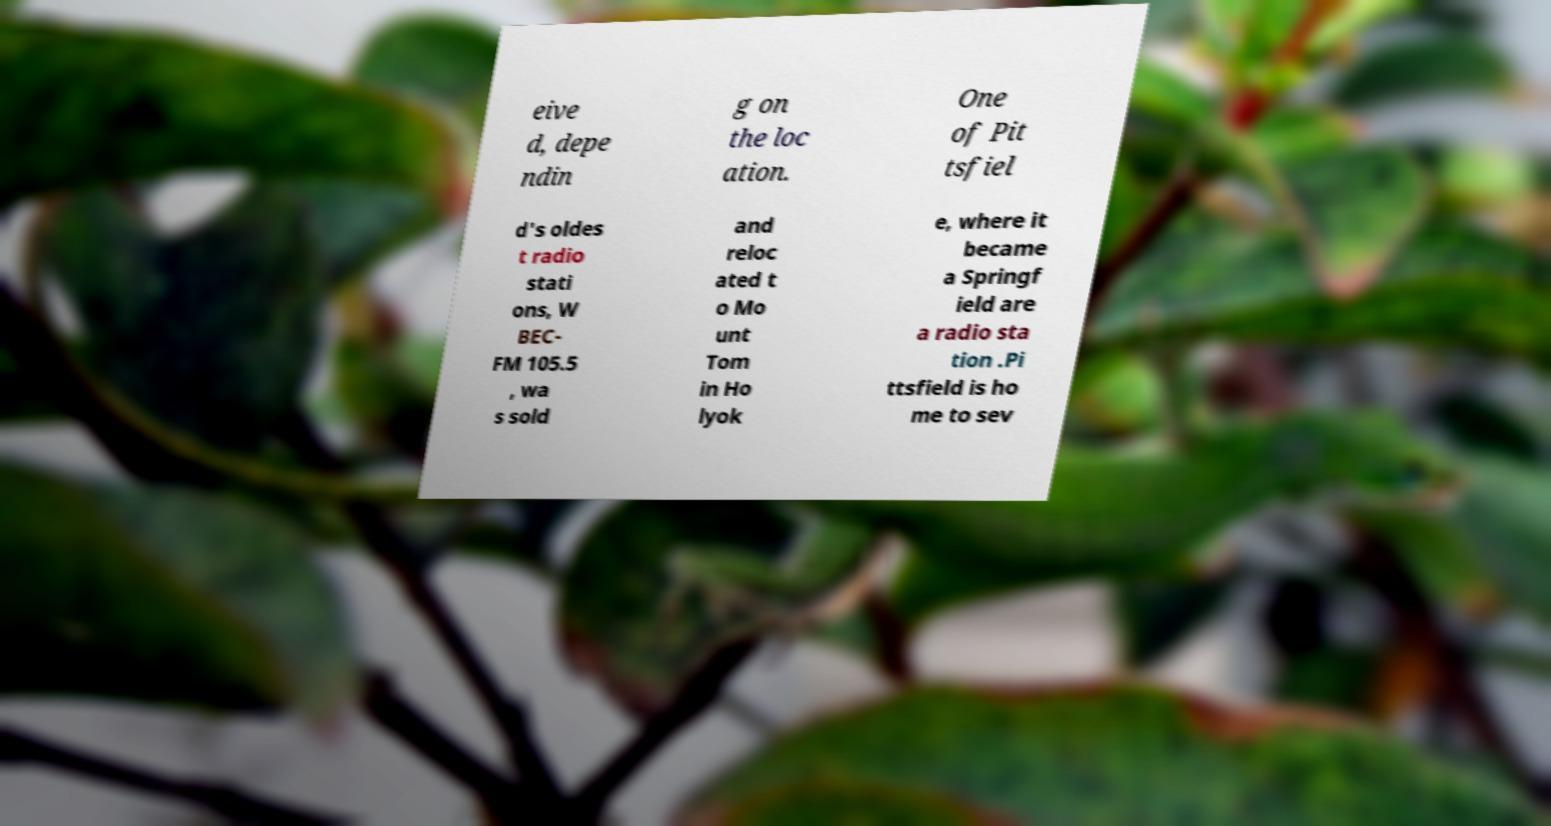What messages or text are displayed in this image? I need them in a readable, typed format. eive d, depe ndin g on the loc ation. One of Pit tsfiel d's oldes t radio stati ons, W BEC- FM 105.5 , wa s sold and reloc ated t o Mo unt Tom in Ho lyok e, where it became a Springf ield are a radio sta tion .Pi ttsfield is ho me to sev 